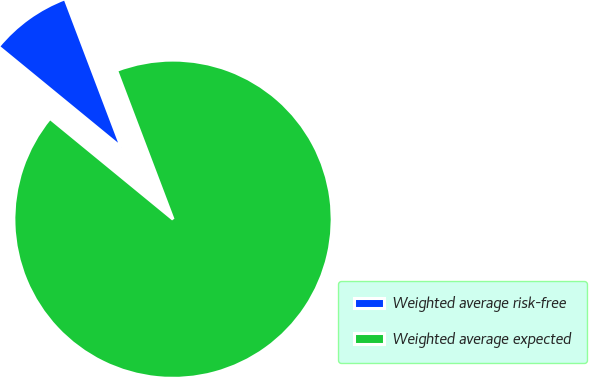Convert chart. <chart><loc_0><loc_0><loc_500><loc_500><pie_chart><fcel>Weighted average risk-free<fcel>Weighted average expected<nl><fcel>8.3%<fcel>91.7%<nl></chart> 